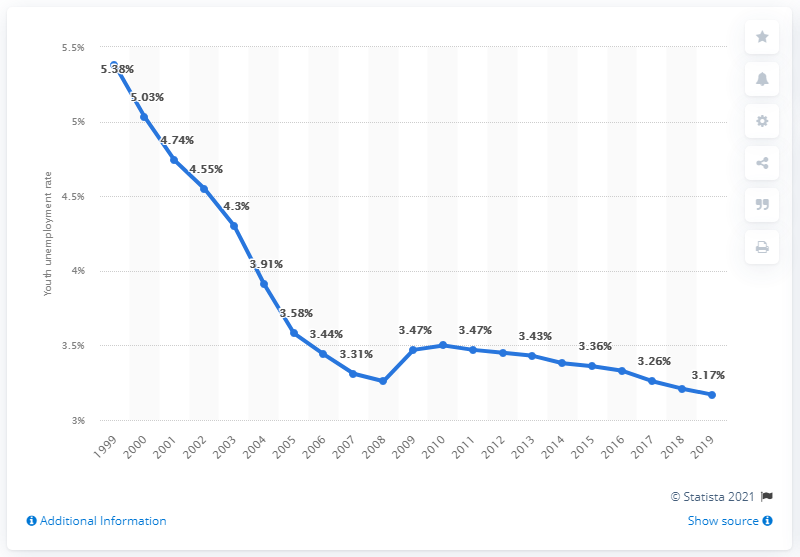Indicate a few pertinent items in this graphic. The highest unemployment rate in Ethiopia during the years 1999 and 2019 was 2.21%, while the lowest rate was recorded during the same period. In 2019, the youth unemployment rate in Ethiopia was 3.17%. The youth unemployment rate in Ethiopia in the year 2017 was 3.26%. 